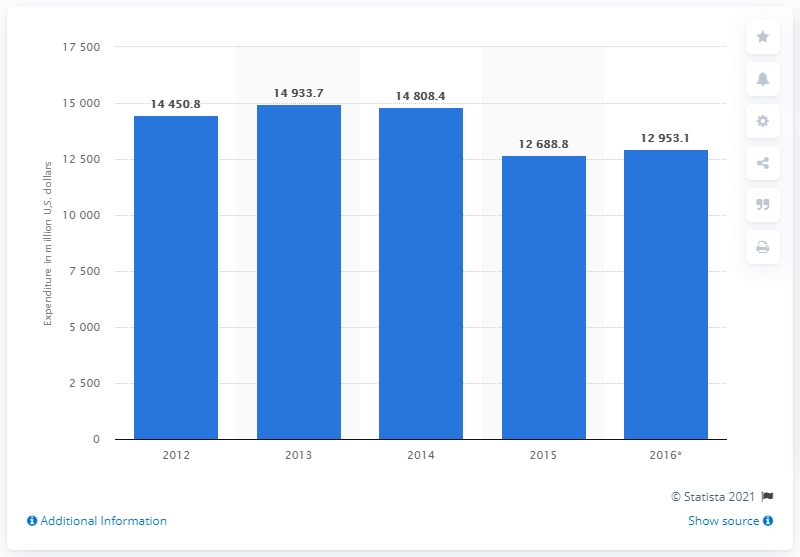Point out several critical features in this image. The projected expenditure on food in the Czech Republic in 2016 is expected to be approximately 129,53.1. In the period between 2012 and 2016, the year with the highest consumer expenditure on food in the Czech Republic was 2013. The total amount of money spent by consumers on food in the Czech Republic in 2015 and 2014 was approximately 27,497.2 million US dollars. 